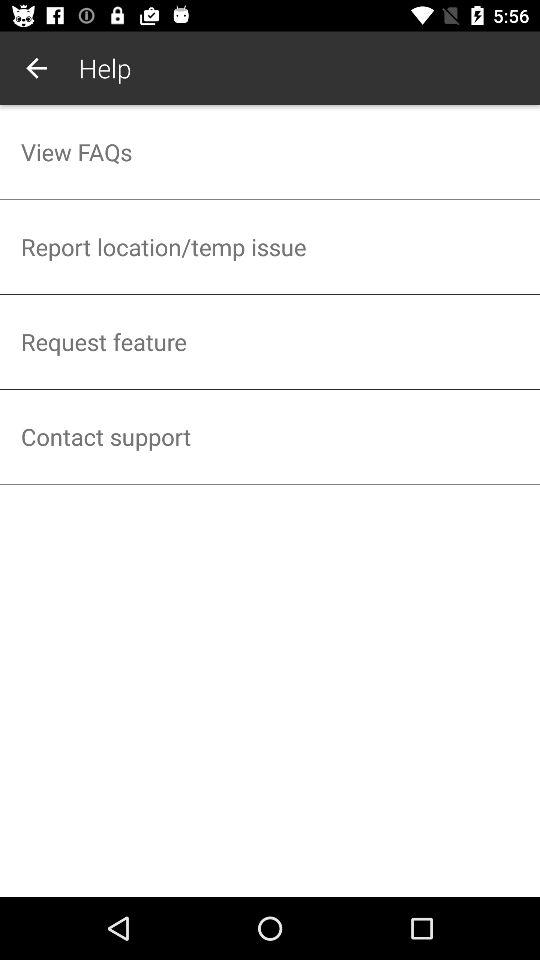How many items are in the help menu?
Answer the question using a single word or phrase. 4 